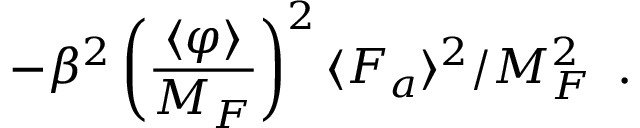Convert formula to latex. <formula><loc_0><loc_0><loc_500><loc_500>- \beta ^ { 2 } \left ( \frac { \langle \varphi \rangle } { M _ { F } } \right ) ^ { 2 } \langle F _ { a } \rangle ^ { 2 } / M _ { F } ^ { 2 } \, .</formula> 